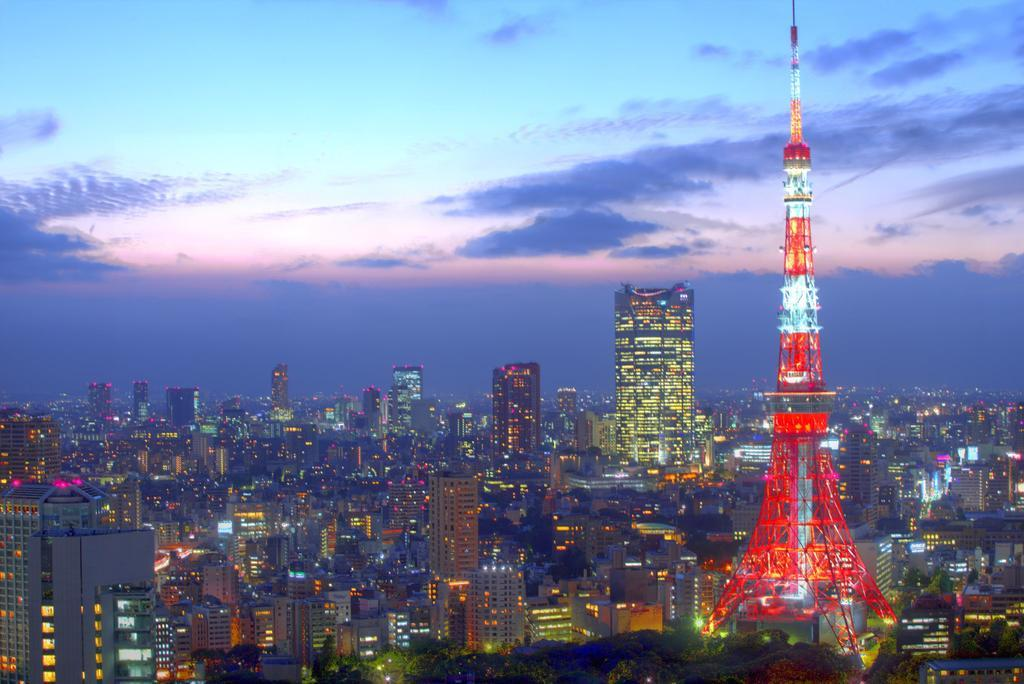What structures are located in the middle of the image? There are buildings in the middle of the image. What famous landmark can be seen on the right side of the image? There appears to be an Eiffel tower on the right side of the image. What is visible at the top of the image? The sky is visible at the top of the image. What type of arch can be seen supporting the Eiffel tower in the image? There is no arch supporting the Eiffel tower in the image; it stands independently. What wire is connected to the top of the Eiffel tower in the image? There is no wire connected to the top of the Eiffel tower in the image. 